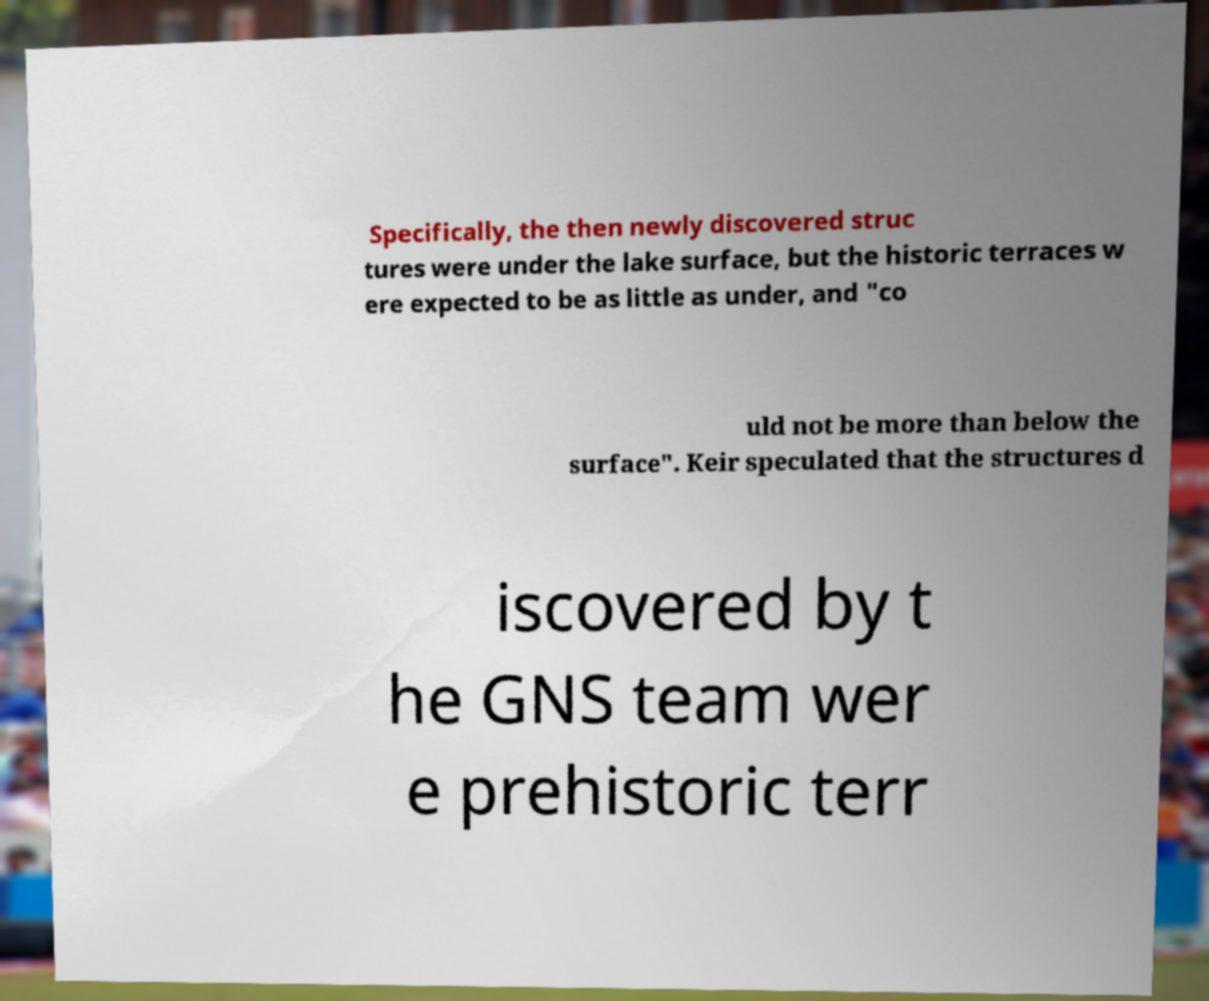There's text embedded in this image that I need extracted. Can you transcribe it verbatim? Specifically, the then newly discovered struc tures were under the lake surface, but the historic terraces w ere expected to be as little as under, and "co uld not be more than below the surface". Keir speculated that the structures d iscovered by t he GNS team wer e prehistoric terr 